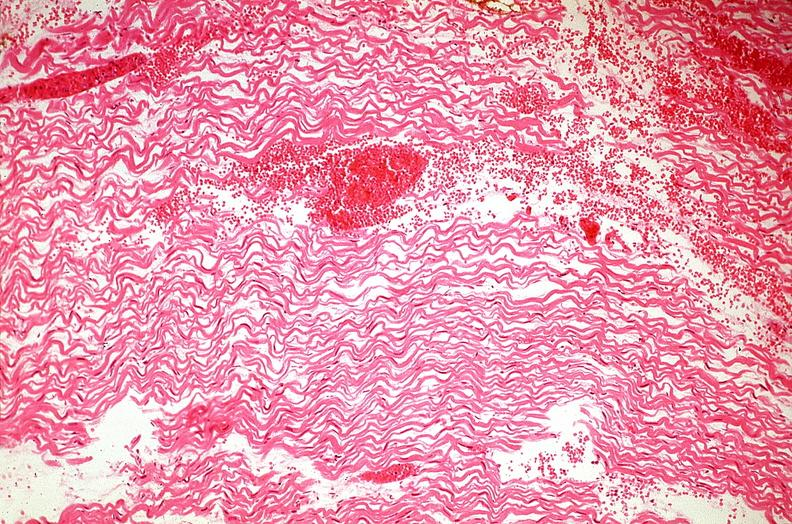what does this image show?
Answer the question using a single word or phrase. Heart 